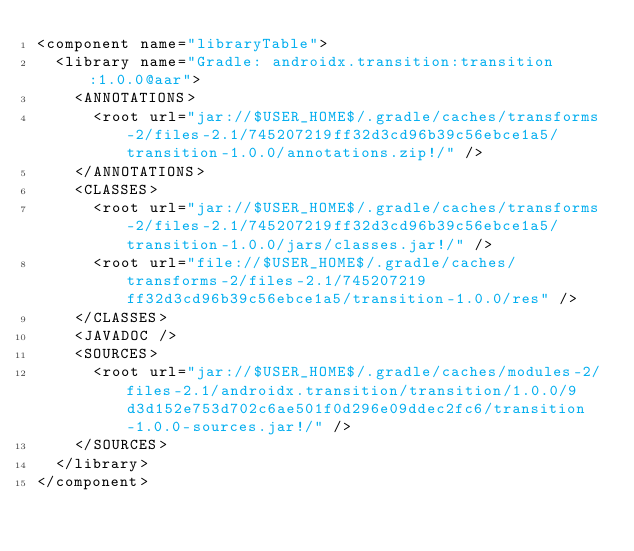<code> <loc_0><loc_0><loc_500><loc_500><_XML_><component name="libraryTable">
  <library name="Gradle: androidx.transition:transition:1.0.0@aar">
    <ANNOTATIONS>
      <root url="jar://$USER_HOME$/.gradle/caches/transforms-2/files-2.1/745207219ff32d3cd96b39c56ebce1a5/transition-1.0.0/annotations.zip!/" />
    </ANNOTATIONS>
    <CLASSES>
      <root url="jar://$USER_HOME$/.gradle/caches/transforms-2/files-2.1/745207219ff32d3cd96b39c56ebce1a5/transition-1.0.0/jars/classes.jar!/" />
      <root url="file://$USER_HOME$/.gradle/caches/transforms-2/files-2.1/745207219ff32d3cd96b39c56ebce1a5/transition-1.0.0/res" />
    </CLASSES>
    <JAVADOC />
    <SOURCES>
      <root url="jar://$USER_HOME$/.gradle/caches/modules-2/files-2.1/androidx.transition/transition/1.0.0/9d3d152e753d702c6ae501f0d296e09ddec2fc6/transition-1.0.0-sources.jar!/" />
    </SOURCES>
  </library>
</component></code> 